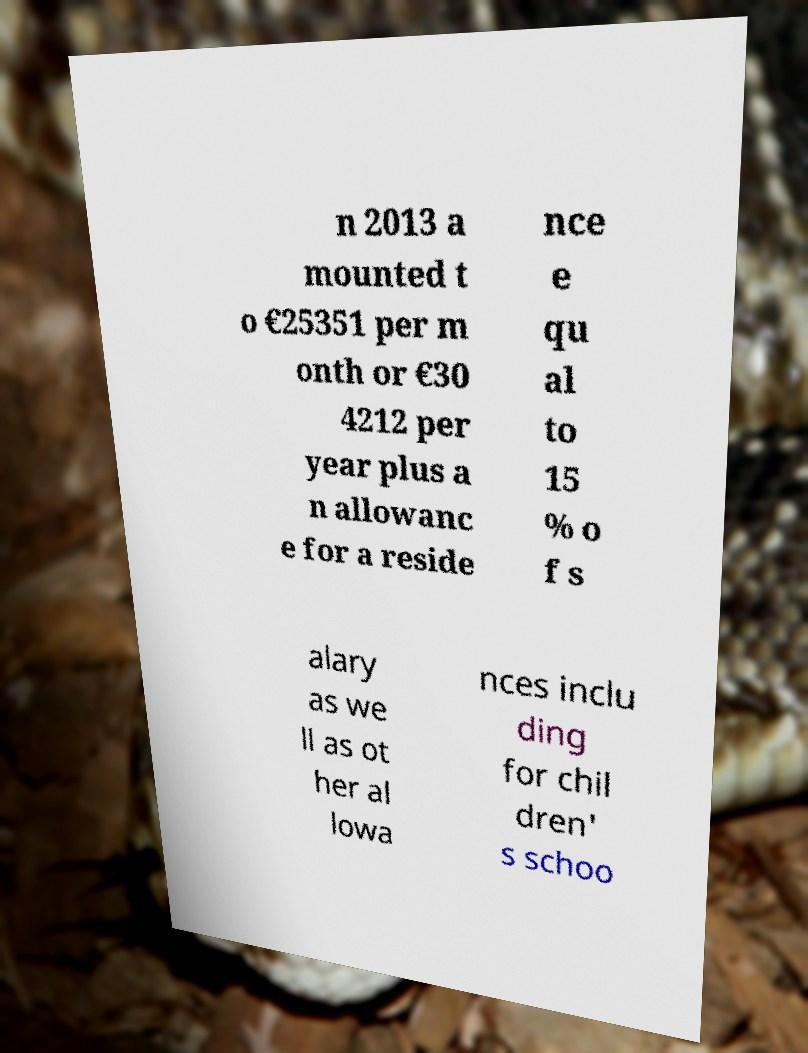Could you assist in decoding the text presented in this image and type it out clearly? n 2013 a mounted t o €25351 per m onth or €30 4212 per year plus a n allowanc e for a reside nce e qu al to 15 % o f s alary as we ll as ot her al lowa nces inclu ding for chil dren' s schoo 